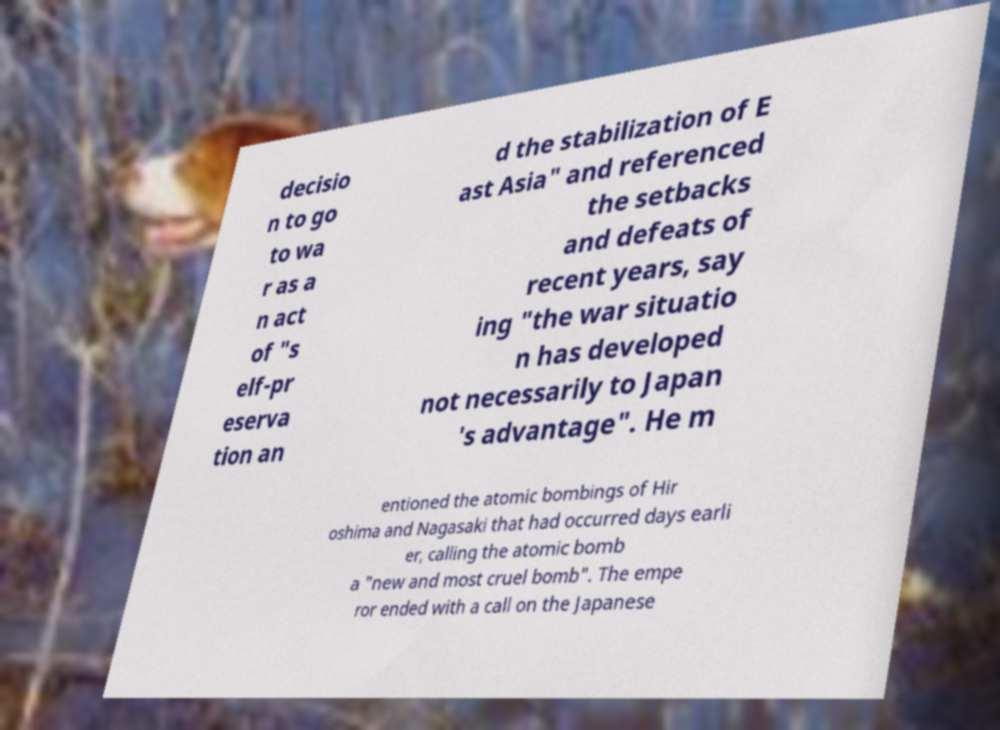I need the written content from this picture converted into text. Can you do that? decisio n to go to wa r as a n act of "s elf-pr eserva tion an d the stabilization of E ast Asia" and referenced the setbacks and defeats of recent years, say ing "the war situatio n has developed not necessarily to Japan 's advantage". He m entioned the atomic bombings of Hir oshima and Nagasaki that had occurred days earli er, calling the atomic bomb a "new and most cruel bomb". The empe ror ended with a call on the Japanese 